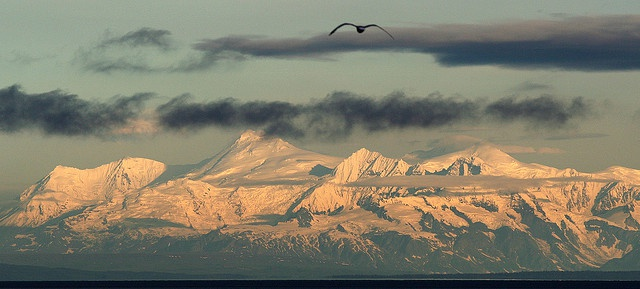Describe the objects in this image and their specific colors. I can see a bird in darkgray, gray, and black tones in this image. 